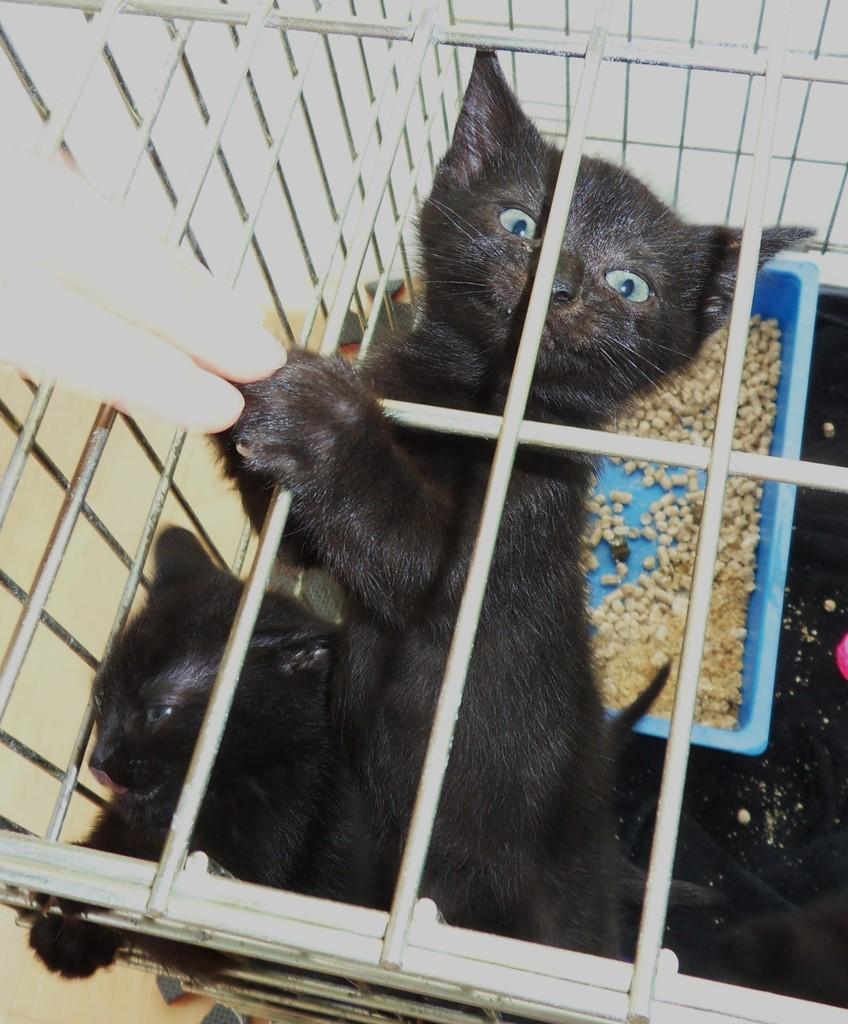Describe this image in one or two sentences. As we can see in the image there are black color cats, tray, human hand and nuts. 